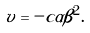<formula> <loc_0><loc_0><loc_500><loc_500>v = - c \alpha \beta ^ { 2 } .</formula> 